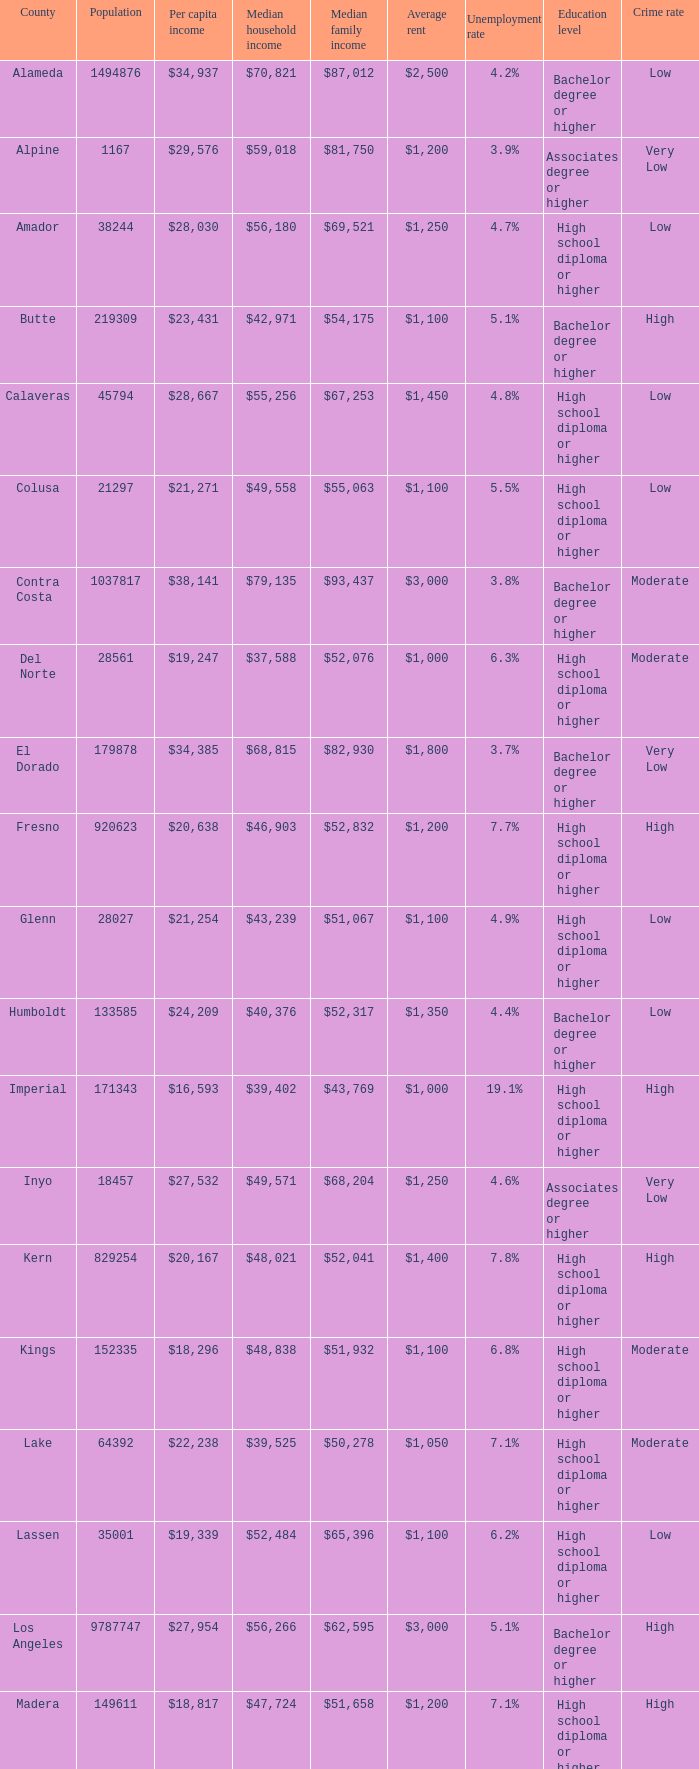What is the median household income of sacramento? $56,553. 